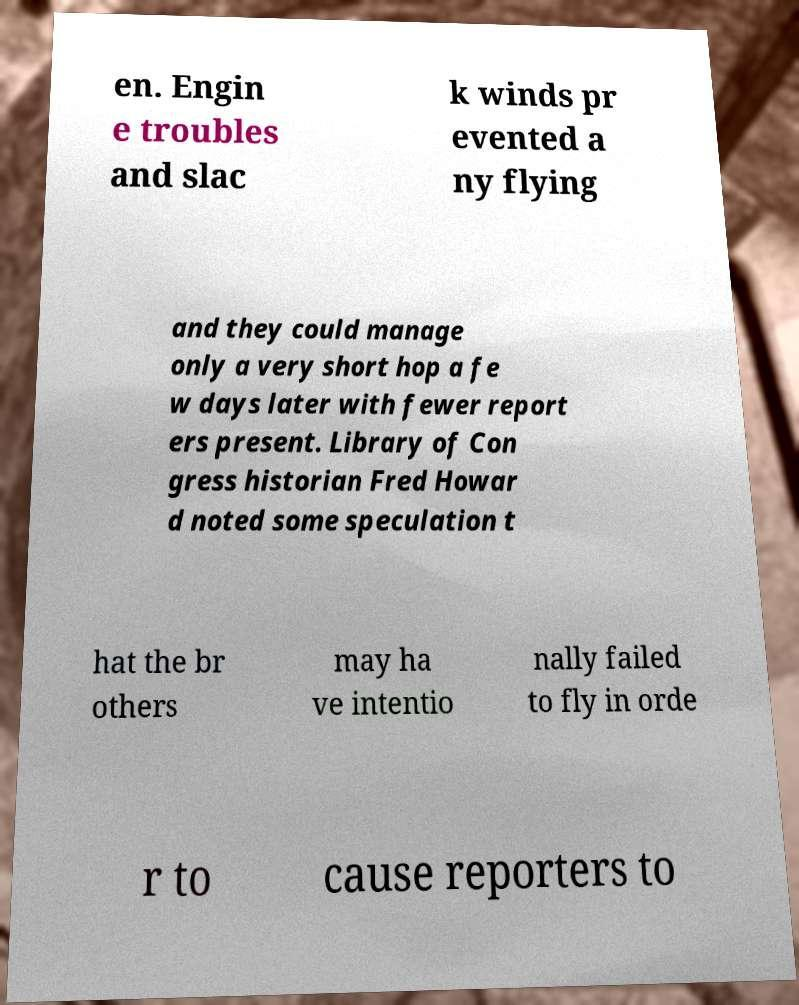I need the written content from this picture converted into text. Can you do that? en. Engin e troubles and slac k winds pr evented a ny flying and they could manage only a very short hop a fe w days later with fewer report ers present. Library of Con gress historian Fred Howar d noted some speculation t hat the br others may ha ve intentio nally failed to fly in orde r to cause reporters to 